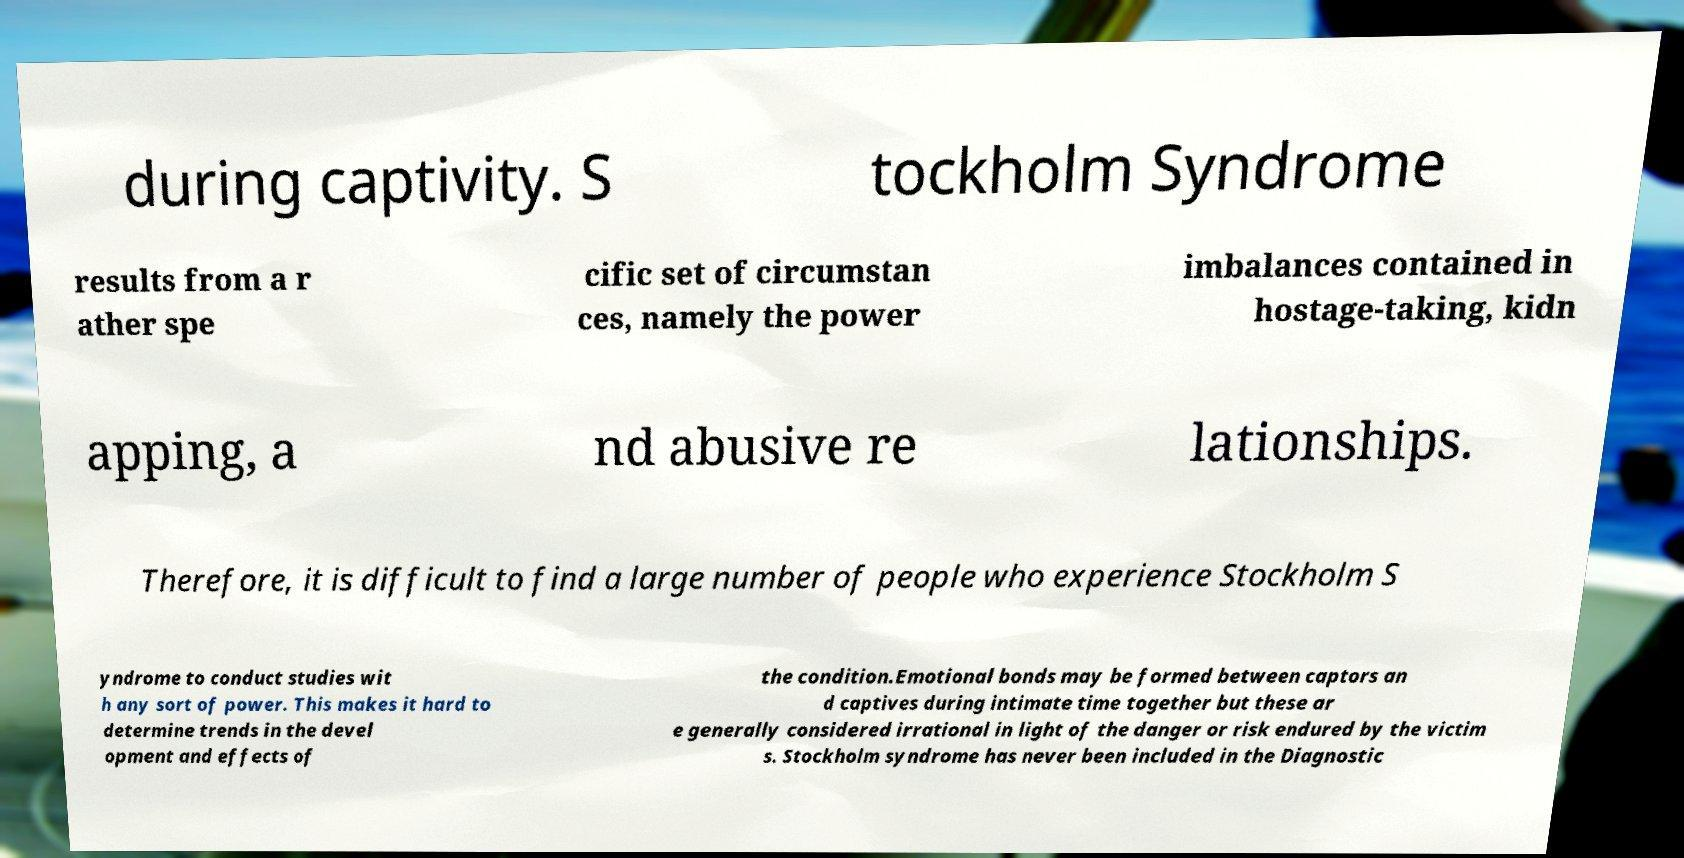Please read and relay the text visible in this image. What does it say? during captivity. S tockholm Syndrome results from a r ather spe cific set of circumstan ces, namely the power imbalances contained in hostage-taking, kidn apping, a nd abusive re lationships. Therefore, it is difficult to find a large number of people who experience Stockholm S yndrome to conduct studies wit h any sort of power. This makes it hard to determine trends in the devel opment and effects of the condition.Emotional bonds may be formed between captors an d captives during intimate time together but these ar e generally considered irrational in light of the danger or risk endured by the victim s. Stockholm syndrome has never been included in the Diagnostic 